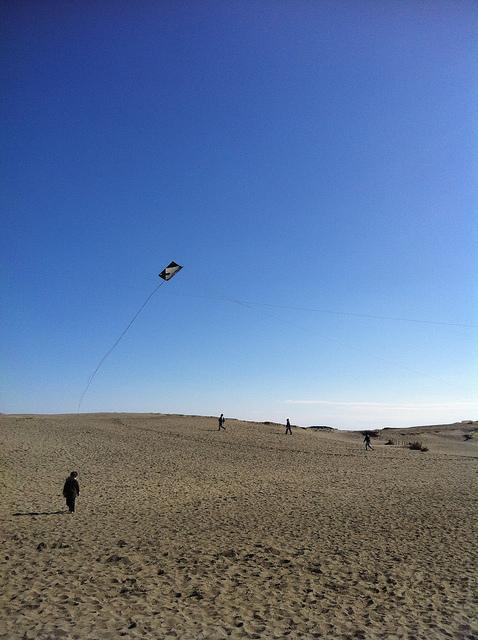How many people are in this picture?
Give a very brief answer. 4. How many donuts have a pumpkin face?
Give a very brief answer. 0. 